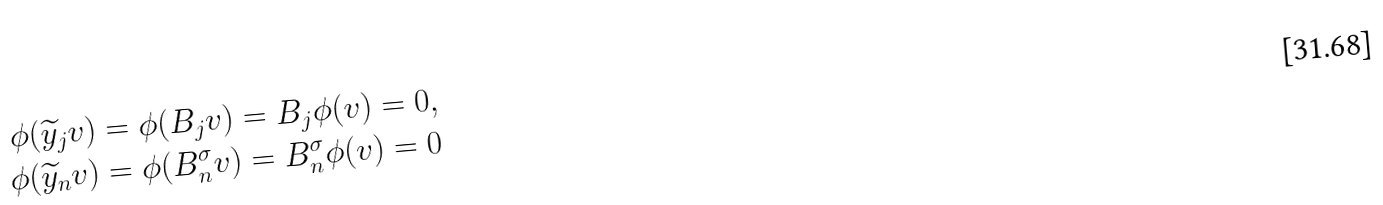Convert formula to latex. <formula><loc_0><loc_0><loc_500><loc_500>\phi ( \widetilde { y } _ { j } v ) & = \phi ( B _ { j } v ) = B _ { j } \phi ( v ) = 0 , \\ \phi ( \widetilde { y } _ { n } v ) & = \phi ( B _ { n } ^ { \sigma } v ) = B _ { n } ^ { \sigma } \phi ( v ) = 0</formula> 